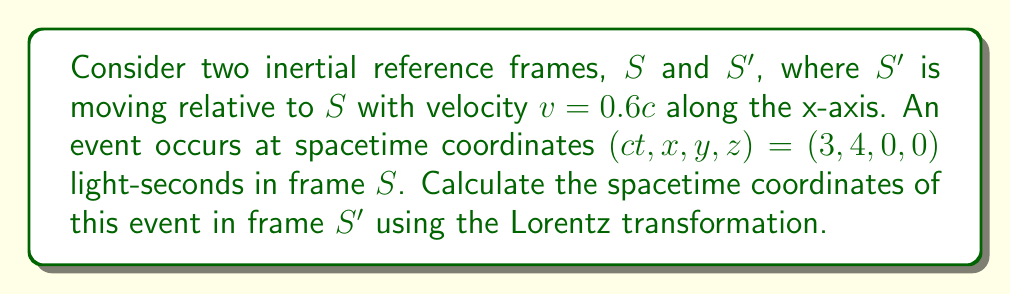Show me your answer to this math problem. To solve this problem, we'll use the Lorentz transformation equations for the ct and x coordinates. The y and z coordinates remain unchanged.

Step 1: Define the Lorentz factor $\gamma$
$$\gamma = \frac{1}{\sqrt{1 - \frac{v^2}{c^2}}} = \frac{1}{\sqrt{1 - 0.6^2}} \approx 1.25$$

Step 2: Apply the Lorentz transformation for ct'
$$ct' = \gamma(ct - \frac{v}{c}x)$$
$$ct' = 1.25(3 - 0.6 \cdot 4) = 1.25(3 - 2.4) = 1.25 \cdot 0.6 = 0.75$$

Step 3: Apply the Lorentz transformation for x'
$$x' = \gamma(x - vt)$$
$$x' = 1.25(4 - 0.6 \cdot 3) = 1.25(4 - 1.8) = 1.25 \cdot 2.2 = 2.75$$

Step 4: Note that y' and z' remain unchanged
$$y' = y = 0$$
$$z' = z = 0$$

Therefore, the spacetime coordinates in frame S' are (0.75, 2.75, 0, 0) light-seconds.
Answer: (0.75, 2.75, 0, 0) light-seconds 